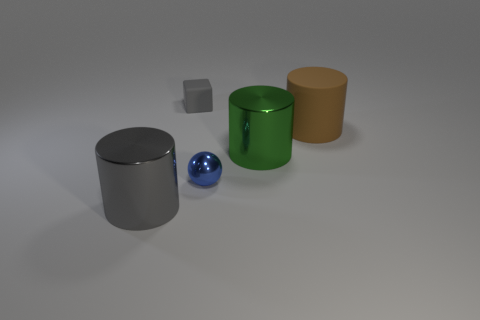How many green metal things are the same shape as the big brown thing?
Provide a short and direct response. 1. How many small balls are there?
Your response must be concise. 1. Is the shape of the big matte thing the same as the gray thing that is in front of the large brown rubber cylinder?
Your response must be concise. Yes. What number of things are either brown rubber cylinders or rubber cylinders that are on the right side of the metal ball?
Offer a terse response. 1. There is a brown thing that is the same shape as the large green metallic thing; what is it made of?
Make the answer very short. Rubber. Does the big shiny thing that is right of the small gray matte cube have the same shape as the big matte thing?
Keep it short and to the point. Yes. Is the number of brown cylinders that are on the right side of the big green metallic thing less than the number of big objects that are in front of the matte block?
Ensure brevity in your answer.  Yes. What number of other objects are the same shape as the large brown rubber thing?
Ensure brevity in your answer.  2. What is the size of the gray thing that is behind the large metallic cylinder that is to the right of the cylinder that is to the left of the small cube?
Provide a succinct answer. Small. What number of gray things are small matte cubes or small metallic cylinders?
Your answer should be compact. 1. 